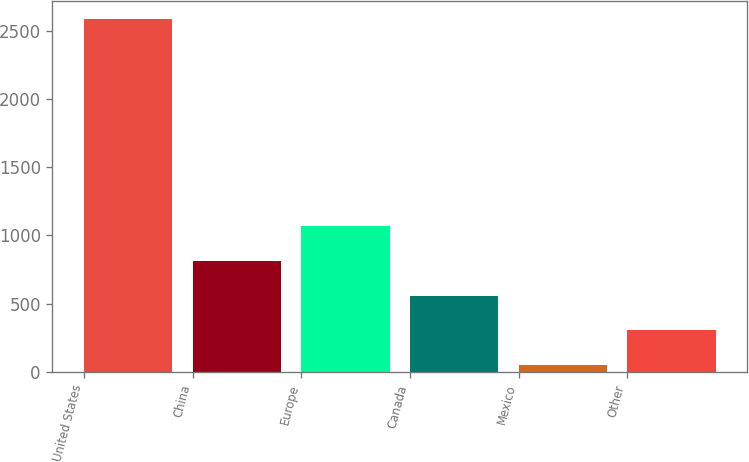<chart> <loc_0><loc_0><loc_500><loc_500><bar_chart><fcel>United States<fcel>China<fcel>Europe<fcel>Canada<fcel>Mexico<fcel>Other<nl><fcel>2589.1<fcel>812.08<fcel>1065.94<fcel>558.22<fcel>50.5<fcel>304.36<nl></chart> 